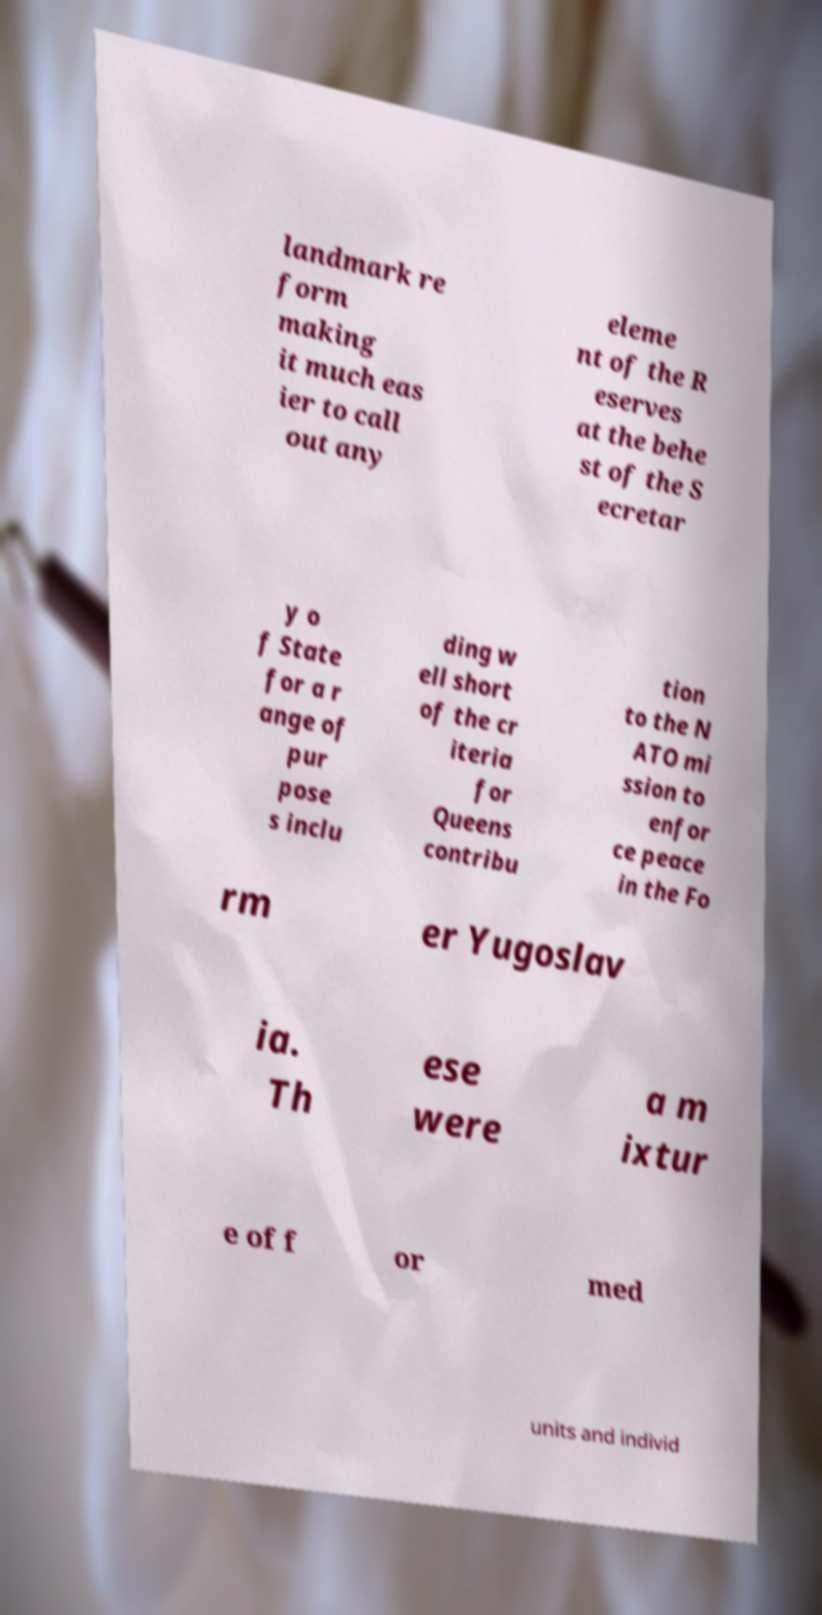Please identify and transcribe the text found in this image. landmark re form making it much eas ier to call out any eleme nt of the R eserves at the behe st of the S ecretar y o f State for a r ange of pur pose s inclu ding w ell short of the cr iteria for Queens contribu tion to the N ATO mi ssion to enfor ce peace in the Fo rm er Yugoslav ia. Th ese were a m ixtur e of f or med units and individ 